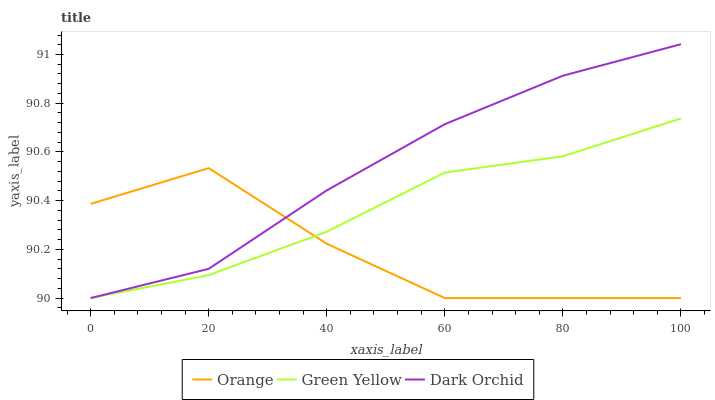Does Orange have the minimum area under the curve?
Answer yes or no. Yes. Does Dark Orchid have the maximum area under the curve?
Answer yes or no. Yes. Does Green Yellow have the minimum area under the curve?
Answer yes or no. No. Does Green Yellow have the maximum area under the curve?
Answer yes or no. No. Is Dark Orchid the smoothest?
Answer yes or no. Yes. Is Orange the roughest?
Answer yes or no. Yes. Is Green Yellow the smoothest?
Answer yes or no. No. Is Green Yellow the roughest?
Answer yes or no. No. Does Dark Orchid have the highest value?
Answer yes or no. Yes. Does Green Yellow have the highest value?
Answer yes or no. No. 